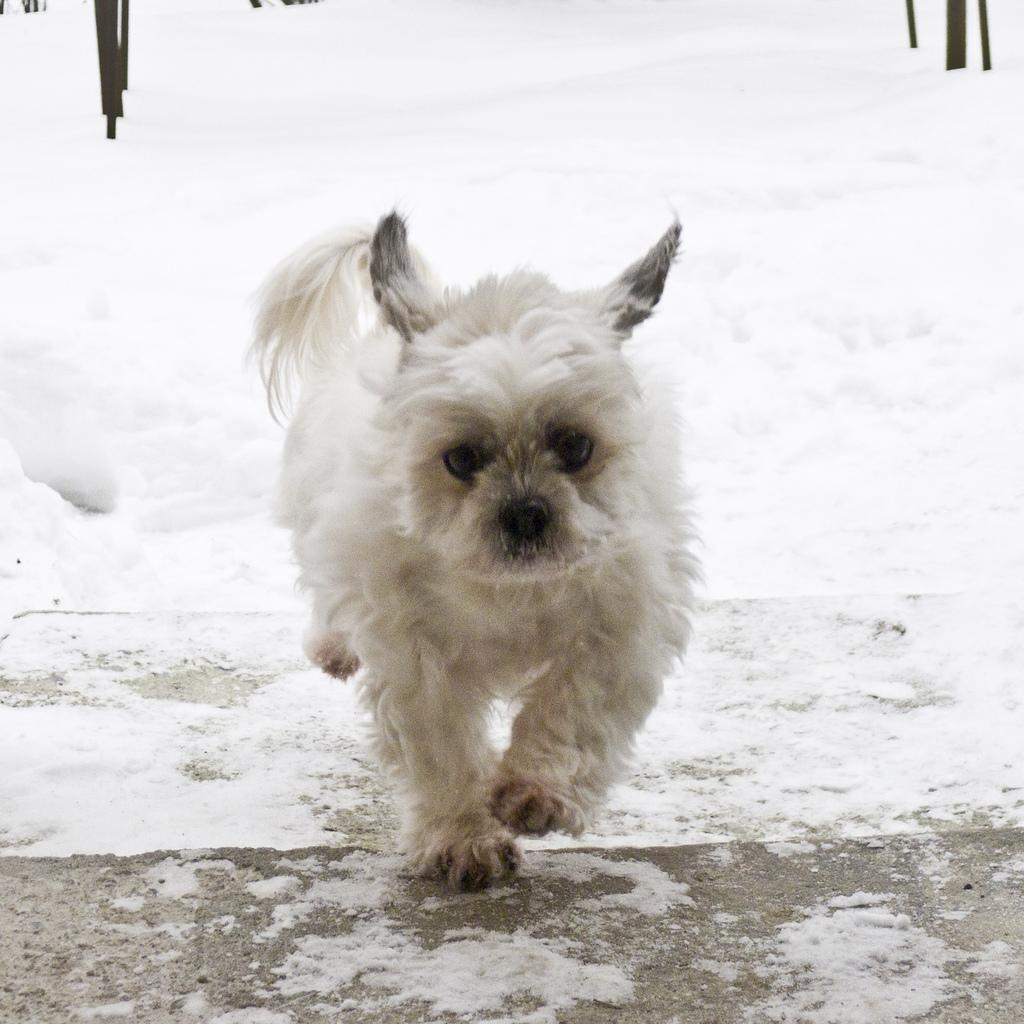What type of animal is in the image? The type of animal cannot be determined from the provided facts. Where is the animal located in the image? The animal is on the ground in the image. What is the weather like in the image? The presence of snow in the image suggests a cold or wintry environment. What can be seen in the background of the image? There are objects in the background of the image, but their specific nature cannot be determined from the provided facts. What type of juice can be seen in the animal's hand in the image? There is no juice or hand present in the image; it features an animal on the ground with snow in the background. 